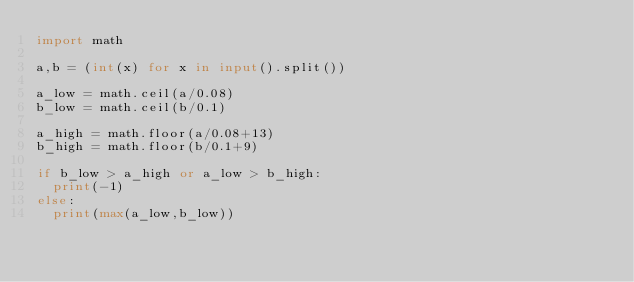<code> <loc_0><loc_0><loc_500><loc_500><_Python_>import math

a,b = (int(x) for x in input().split())

a_low = math.ceil(a/0.08)
b_low = math.ceil(b/0.1)

a_high = math.floor(a/0.08+13)
b_high = math.floor(b/0.1+9)

if b_low > a_high or a_low > b_high:
  print(-1)
else:
  print(max(a_low,b_low))
  </code> 